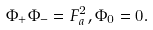Convert formula to latex. <formula><loc_0><loc_0><loc_500><loc_500>\Phi _ { + } \Phi _ { - } = F _ { a } ^ { 2 } , \Phi _ { 0 } = 0 .</formula> 